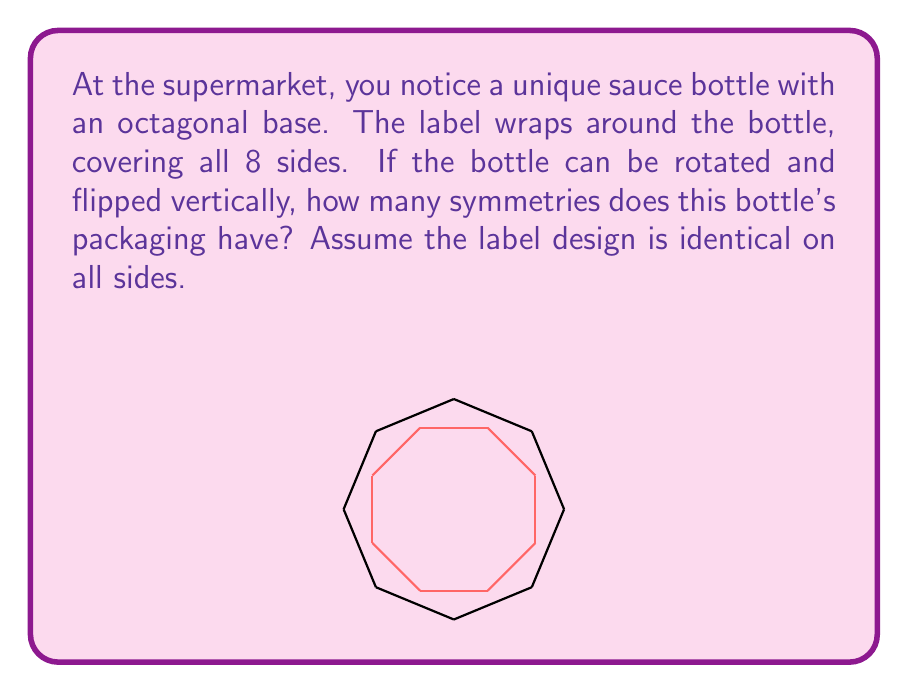Provide a solution to this math problem. To determine the symmetry group of the bottle's packaging, let's follow these steps:

1) First, consider rotational symmetries:
   - The octagonal bottle can be rotated by multiples of 45° (360°/8) to produce identical configurations.
   - There are 8 distinct rotations: 0°, 45°, 90°, 135°, 180°, 225°, 270°, and 315°.

2) Next, consider reflection symmetries:
   - The bottle has 8 lines of reflection, each passing through the center and either a vertex or the midpoint of a side.

3) Now, consider the vertical flip:
   - Flipping the bottle vertically and then rotating it produces new symmetries.
   - This doubles the number of symmetries we've counted so far.

4) Calculate the total number of symmetries:
   - Rotations: 8
   - Reflections: 8
   - Subtotal: 16
   - Doubled due to vertical flip: 16 * 2 = 32

5) Identify the symmetry group:
   - The group of symmetries of a regular octagon is known as the dihedral group $D_8$.
   - With the additional vertical flip, we have the direct product $D_8 \times C_2$, where $C_2$ is the cyclic group of order 2.

Therefore, the symmetry group of the bottle's packaging is $D_8 \times C_2$, which has order 32.
Answer: $D_8 \times C_2$ 